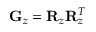<formula> <loc_0><loc_0><loc_500><loc_500>{ G } _ { z } = { R } _ { z } { R } _ { z } ^ { T }</formula> 